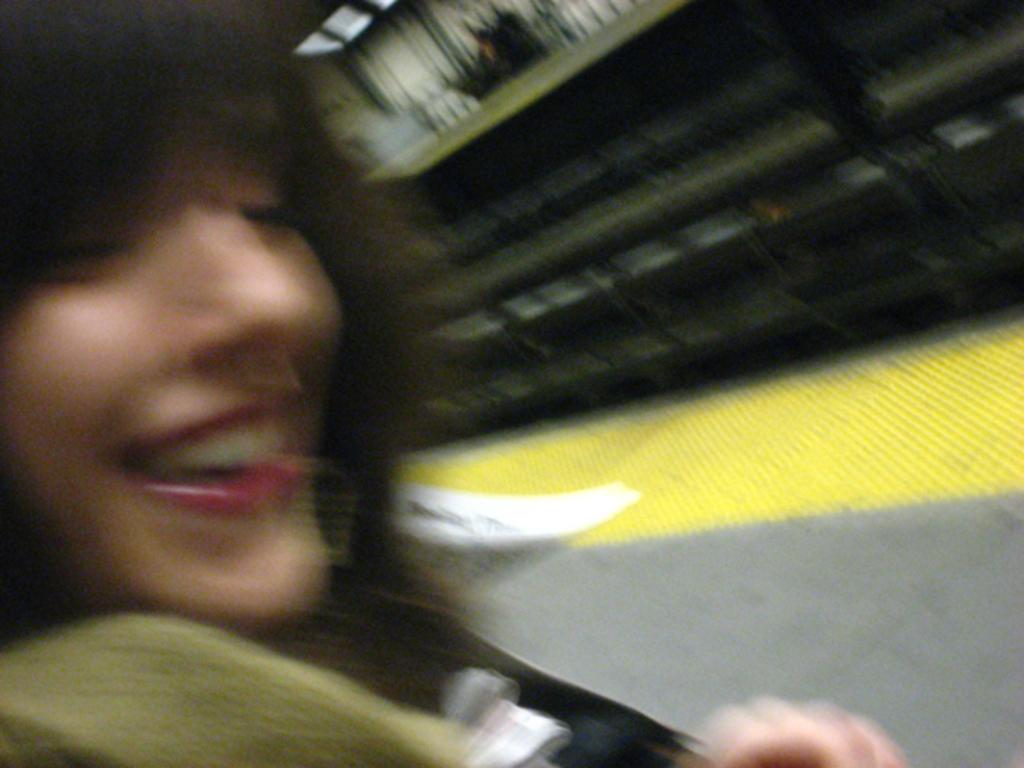Who is the main subject in the image? There is a woman in the image. What is the woman wearing? The woman is wearing a dress. Where is the woman standing? The woman is standing on the ground. What type of force is being exerted by the woman in the image? There is no indication of any force being exerted by the woman in the image. 